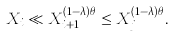Convert formula to latex. <formula><loc_0><loc_0><loc_500><loc_500>X _ { i } \ll X _ { i + 1 } ^ { ( 1 - \lambda ) \theta } \leq X _ { j } ^ { ( 1 - \lambda ) \theta } .</formula> 